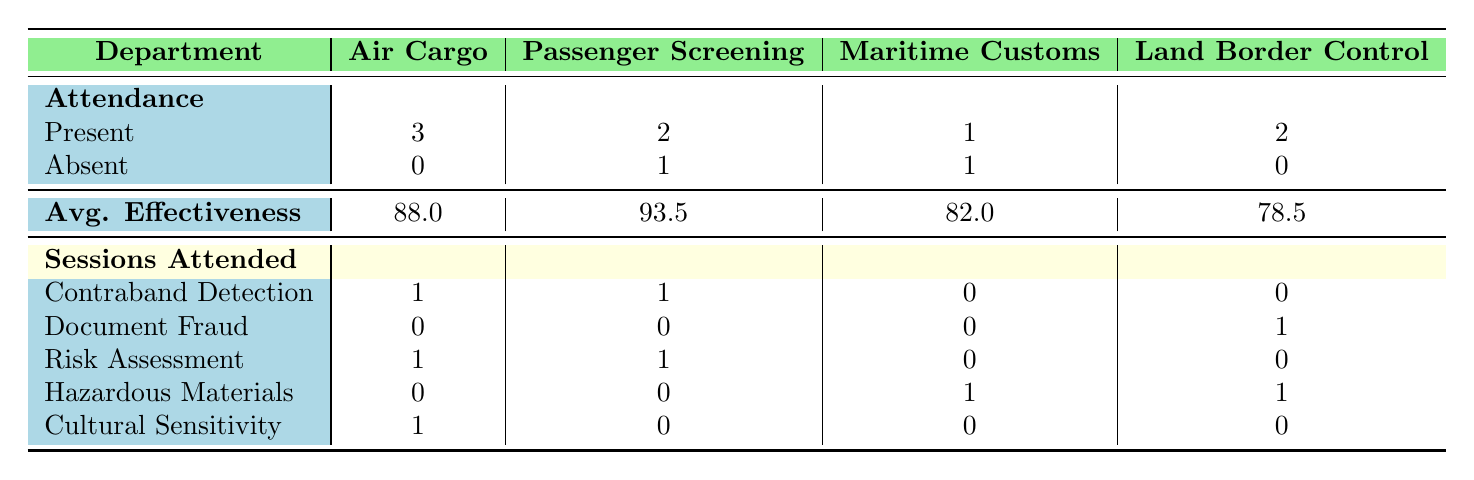What is the total number of attendees from the Air Cargo department? The table indicates that there are three attendees from the Air Cargo department. They are John Smith, Robert Wilson, and Daniel Clark, all marked as Present. Thus, we can count them to get the total number.
Answer: 3 Which department has the highest average effectiveness score? The average effectiveness scores for each department are: Air Cargo (88.0), Passenger Screening (93.5), Maritime Customs (82.0), and Land Border Control (78.5). Comparing these values, we see that the Passenger Screening department has the highest score of 93.5.
Answer: Passenger Screening Did anyone from the Land Border Control department attend the Cultural Sensitivity training session? Referring to the sessions attended row in the table, under Cultural Sensitivity, it shows 0 for Land Border Control, indicating that no member from this department attended this session.
Answer: No How many sessions did the Maritime Customs department attend in total? The table indicates attendance for Maritime Customs as follows: Document Fraud (0), Risk Assessment (0), Hazardous Materials (1), and Cultural Sensitivity (0). The total is 1 session attended by this department.
Answer: 1 What is the difference between the average effectiveness scores of the Air Cargo and Land Border Control departments? The table shows the average effectiveness score for Air Cargo as 88.0 and for Land Border Control as 78.5. To find the difference, we calculate 88.0 - 78.5 = 9.5, meaning Air Cargo scored higher by this amount.
Answer: 9.5 Which session had the most attendees and how many were present? By looking at the sessions attended rows, we see that Contraband Detection had 2 attendees (one each from Air Cargo and Passenger Screening). This is the highest among all sessions, as other sessions either had 1 or fewer attendees. Therefore, the session with the most attendees is Contraband Detection with 2 present.
Answer: Contraband Detection, 2 Did the Maritime Customs department have more absent attendees than present attendees overall? The table indicates that Maritime Customs has 1 present attendee and 1 absent attendee. Since the two counts are equal, the Pasadena Customs department does not have more absentees than present attendees.
Answer: No How many training sessions did the Passenger Screening department participate in? The table indicates sessions attended for Passenger Screening as follows: Contraband Detection (1), Document Fraud (0), Risk Assessment (1), Hazardous Materials (0), and Cultural Sensitivity (0). Summing these, we have 1 + 0 + 1 + 0 + 0 = 2 sessions attended by Passenger Screening.
Answer: 2 